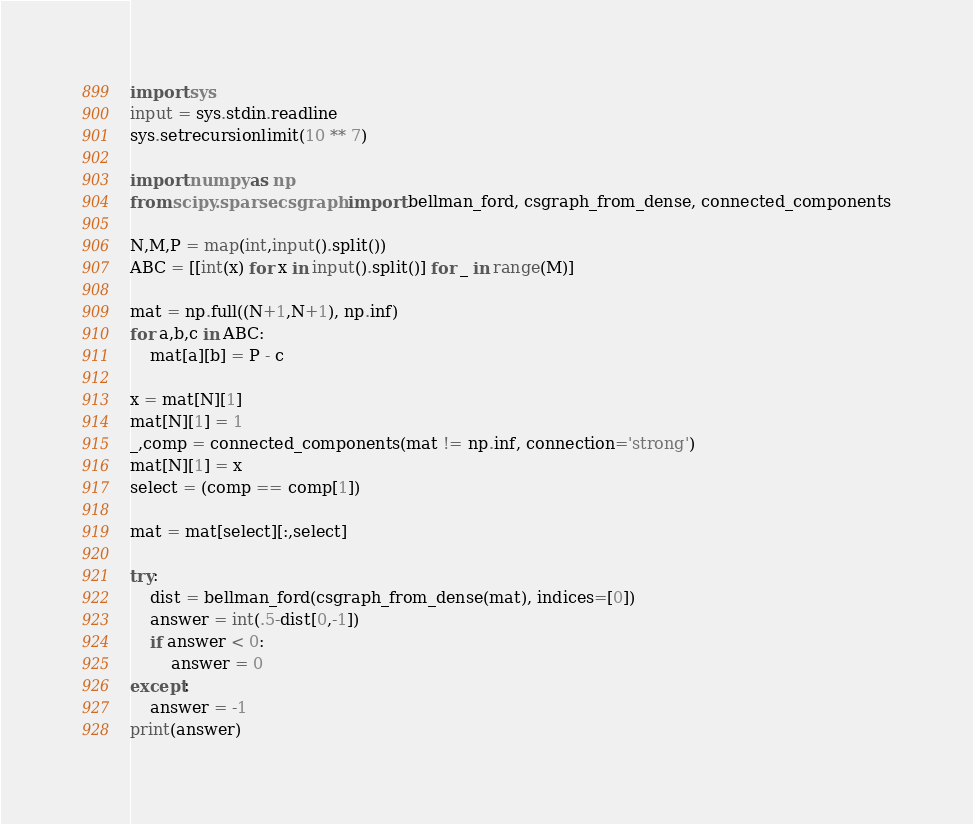<code> <loc_0><loc_0><loc_500><loc_500><_Python_>import sys
input = sys.stdin.readline
sys.setrecursionlimit(10 ** 7)

import numpy as np
from scipy.sparse.csgraph import bellman_ford, csgraph_from_dense, connected_components

N,M,P = map(int,input().split())
ABC = [[int(x) for x in input().split()] for _ in range(M)]

mat = np.full((N+1,N+1), np.inf)
for a,b,c in ABC:
    mat[a][b] = P - c

x = mat[N][1]
mat[N][1] = 1
_,comp = connected_components(mat != np.inf, connection='strong')
mat[N][1] = x
select = (comp == comp[1])

mat = mat[select][:,select]

try:
    dist = bellman_ford(csgraph_from_dense(mat), indices=[0])
    answer = int(.5-dist[0,-1])
    if answer < 0:
        answer = 0
except:
    answer = -1
print(answer)
</code> 